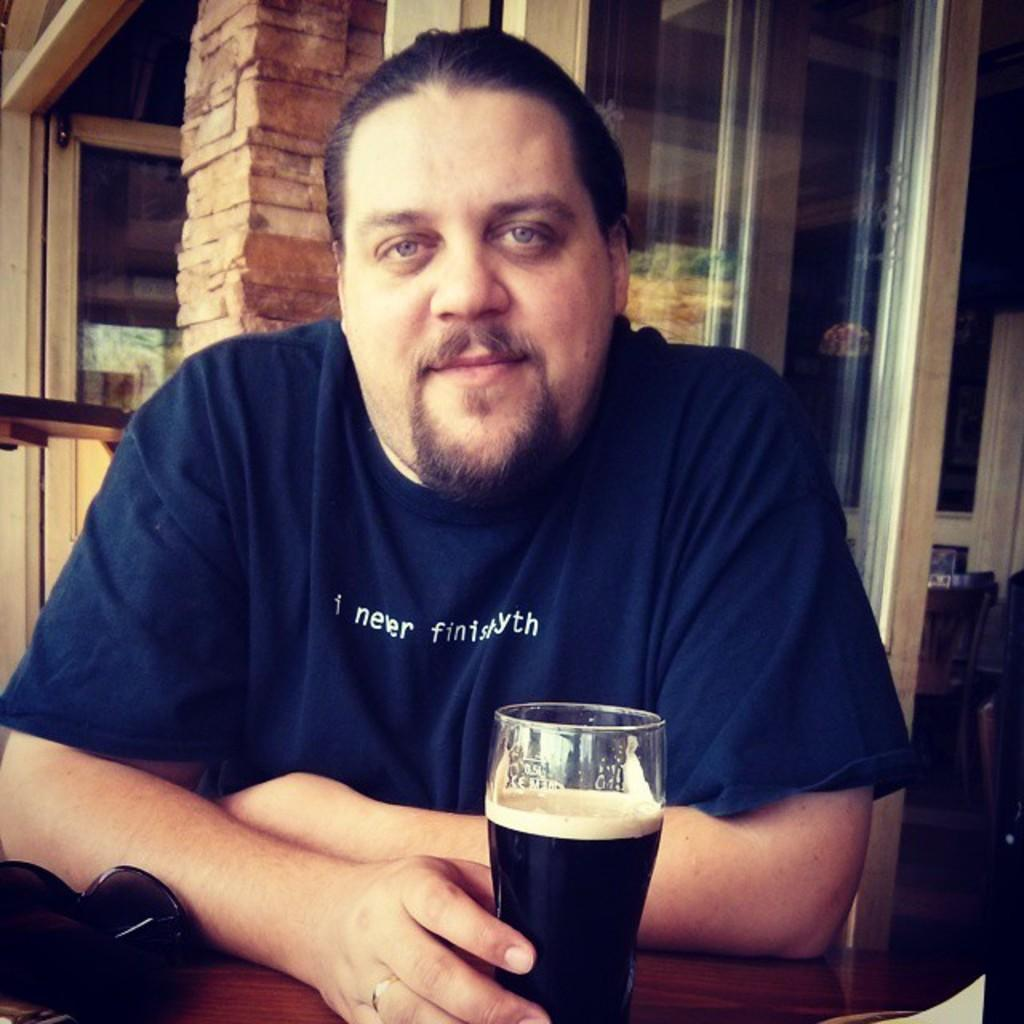Who is present in the image? There is a man in the image. What is the man doing in the image? The man is sitting on a chair and holding a glass with a drink in his hand. What is the man's facial expression in the image? The man is smiling in the image. What can be seen in the background of the image? There is a pillar, doors, and windows in the background of the image. How many dimes can be seen on the boat in the image? There is no boat or dimes present in the image. What is the man's birth date in the image? The image does not provide information about the man's birth date. 